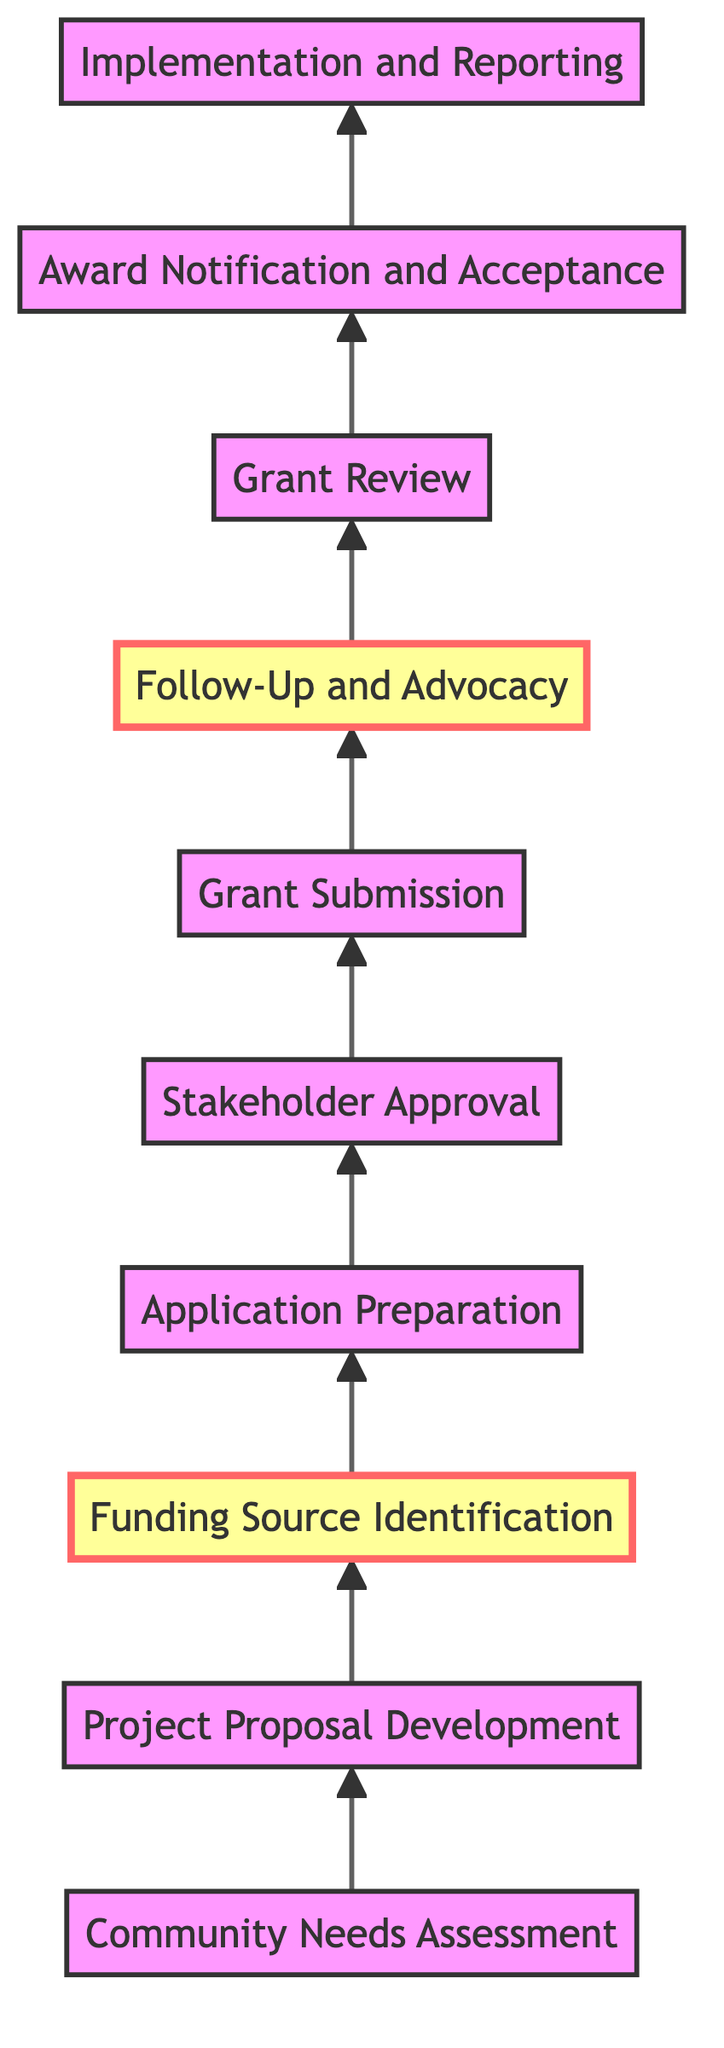What is the first step in the grant application process? The diagram indicates that the first step in the grant application process is the "Community Needs Assessment." This node is the starting point, having no preceding nodes.
Answer: Community Needs Assessment How many total steps are in the process? By counting the nodes in the diagram, there are ten distinct steps depicted from the beginning to the end of the grant application process.
Answer: Ten Which step comes after "Application Preparation"? Following the "Application Preparation" step, the diagram shows that the next step is "Stakeholder Approval." This can be confirmed by looking at the flow direction pointed upwards to the next node.
Answer: Stakeholder Approval What is the last step of the grant application process? The final step in the process, as indicated at the top of the diagram, is "Implementation and Reporting," which concludes the flow of the grant application sequence.
Answer: Implementation and Reporting What step has a highlighted section to indicate its importance? The diagram highlights "Funding Source Identification" and "Follow-Up and Advocacy" in different colors. This indicates that these steps are likely crucial and may warrant additional attention within the process.
Answer: Funding Source Identification, Follow-Up and Advocacy What do stakeholders need to approve before submission? According to the flow, the "Stakeholder Approval" step indicates that approvals must be obtained from essential stakeholders prior to the "Grant Submission" step.
Answer: Necessary approvals Which step directly precedes "Award Notification and Acceptance"? The step immediately before "Award Notification and Acceptance" in the upward flow is "Grant Review," indicating that the review process occurs after grant submission and before notification of results.
Answer: Grant Review What activity follows the "Grant Review" stage? After the "Grant Review" stage, the subsequent activity is "Award Notification and Acceptance," which represents the point at which a decision is communicated to the applicants.
Answer: Award Notification and Acceptance What role does liaison with grant administrators perform? "Follow-Up and Advocacy" focuses on engaging with grant administrators. This step emphasizes maintaining communication and potentially influencing the decision-making process with the backing of the Lieutenant Governor.
Answer: Engaging with grant administrators 